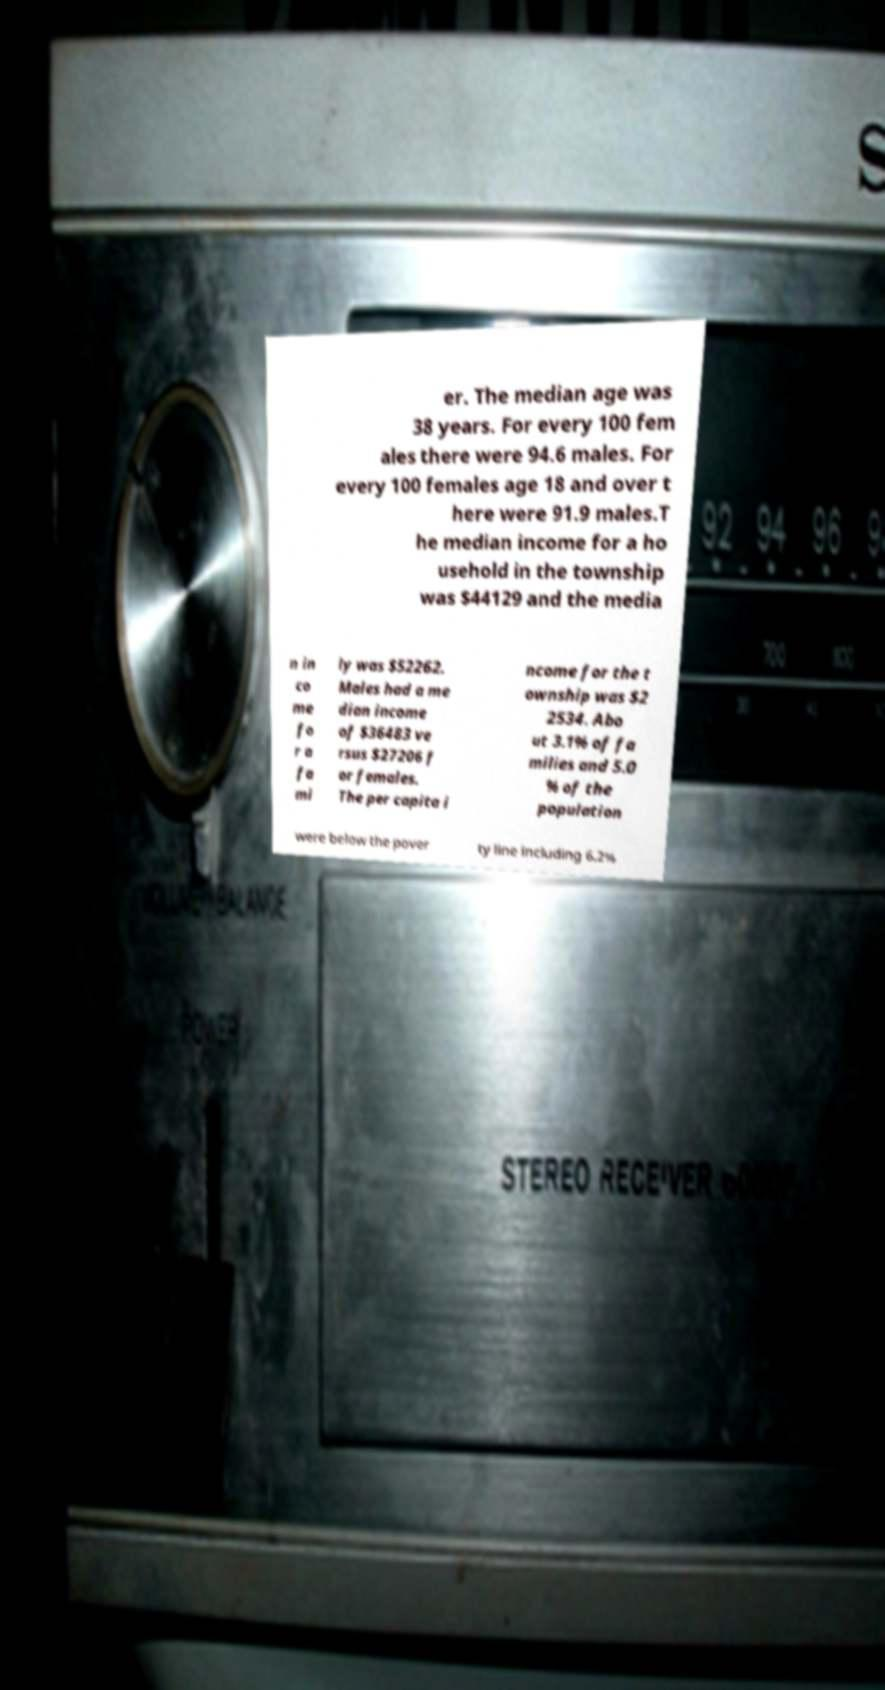Please read and relay the text visible in this image. What does it say? er. The median age was 38 years. For every 100 fem ales there were 94.6 males. For every 100 females age 18 and over t here were 91.9 males.T he median income for a ho usehold in the township was $44129 and the media n in co me fo r a fa mi ly was $52262. Males had a me dian income of $36483 ve rsus $27206 f or females. The per capita i ncome for the t ownship was $2 2534. Abo ut 3.1% of fa milies and 5.0 % of the population were below the pover ty line including 6.2% 